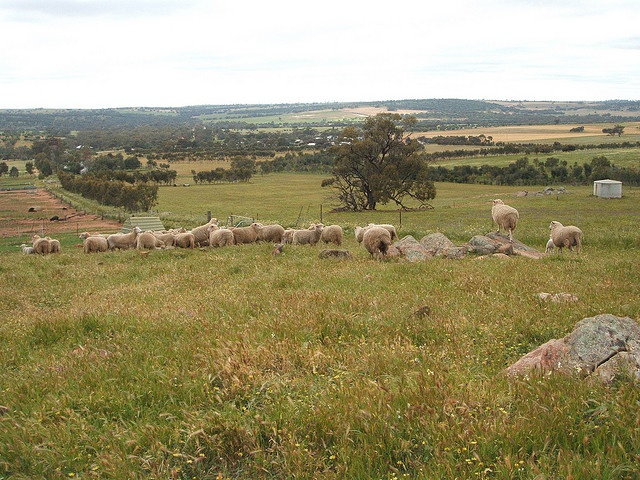Describe the objects in this image and their specific colors. I can see sheep in white, tan, gray, and olive tones, sheep in white, tan, and gray tones, sheep in white, gray, and tan tones, sheep in white, gray, maroon, tan, and black tones, and sheep in white, gray, and tan tones in this image. 